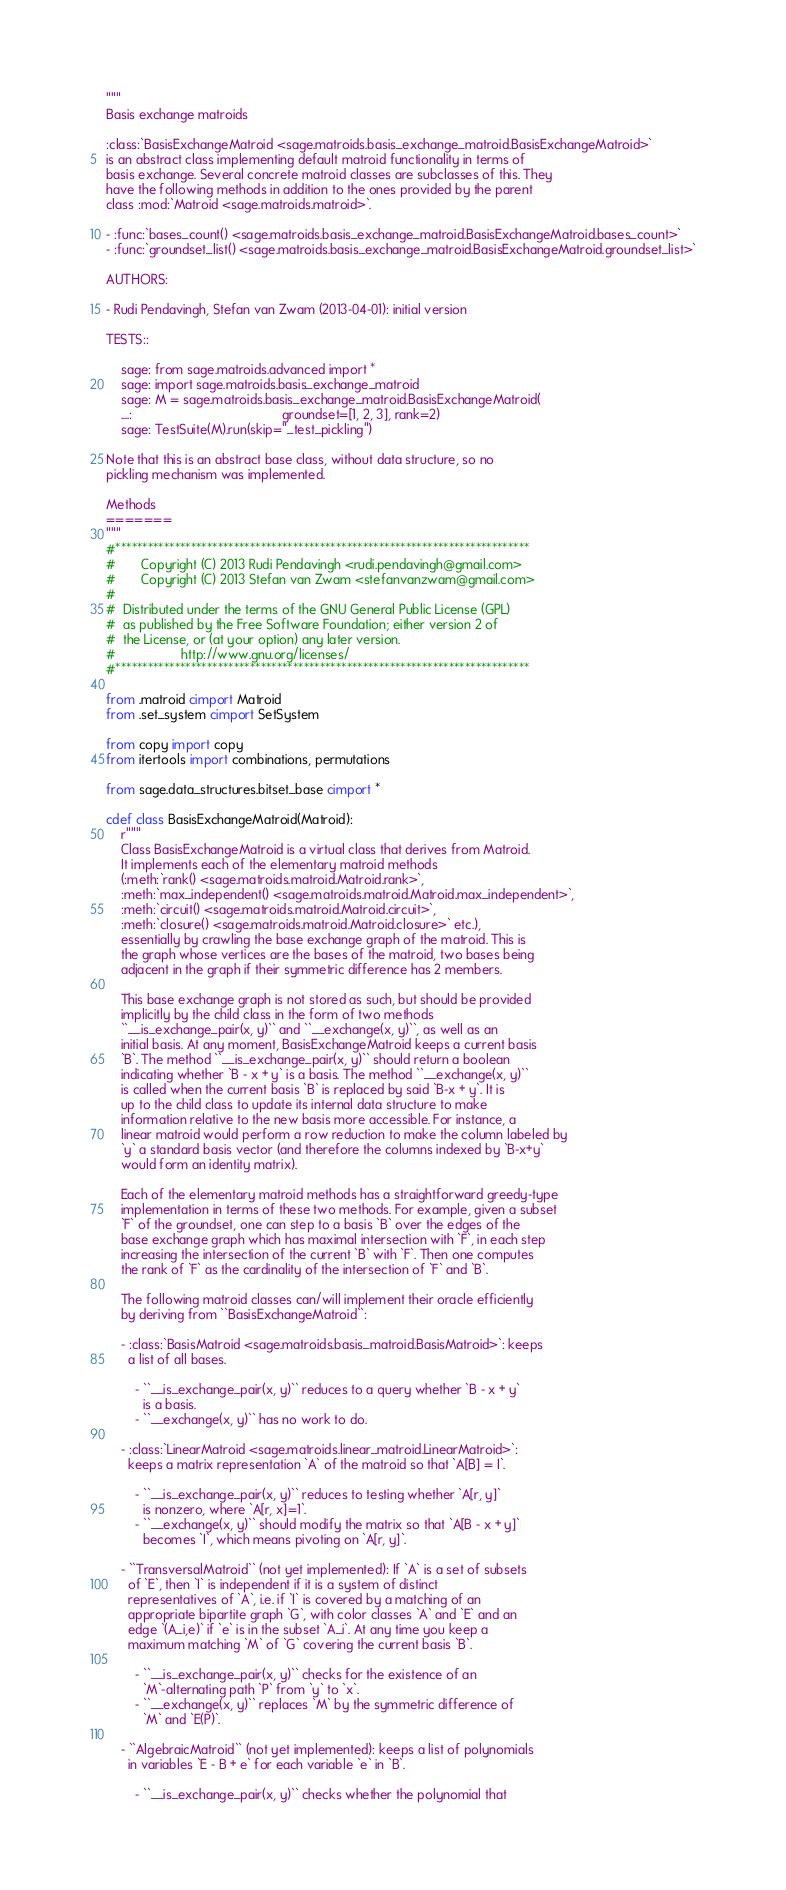<code> <loc_0><loc_0><loc_500><loc_500><_Cython_>"""
Basis exchange matroids

:class:`BasisExchangeMatroid <sage.matroids.basis_exchange_matroid.BasisExchangeMatroid>`
is an abstract class implementing default matroid functionality in terms of
basis exchange. Several concrete matroid classes are subclasses of this. They
have the following methods in addition to the ones provided by the parent
class :mod:`Matroid <sage.matroids.matroid>`.

- :func:`bases_count() <sage.matroids.basis_exchange_matroid.BasisExchangeMatroid.bases_count>`
- :func:`groundset_list() <sage.matroids.basis_exchange_matroid.BasisExchangeMatroid.groundset_list>`

AUTHORS:

- Rudi Pendavingh, Stefan van Zwam (2013-04-01): initial version

TESTS::

    sage: from sage.matroids.advanced import *
    sage: import sage.matroids.basis_exchange_matroid
    sage: M = sage.matroids.basis_exchange_matroid.BasisExchangeMatroid(
    ....:                                         groundset=[1, 2, 3], rank=2)
    sage: TestSuite(M).run(skip="_test_pickling")

Note that this is an abstract base class, without data structure, so no
pickling mechanism was implemented.

Methods
=======
"""
#*****************************************************************************
#       Copyright (C) 2013 Rudi Pendavingh <rudi.pendavingh@gmail.com>
#       Copyright (C) 2013 Stefan van Zwam <stefanvanzwam@gmail.com>
#
#  Distributed under the terms of the GNU General Public License (GPL)
#  as published by the Free Software Foundation; either version 2 of
#  the License, or (at your option) any later version.
#                  http://www.gnu.org/licenses/
#*****************************************************************************

from .matroid cimport Matroid
from .set_system cimport SetSystem

from copy import copy
from itertools import combinations, permutations

from sage.data_structures.bitset_base cimport *

cdef class BasisExchangeMatroid(Matroid):
    r"""
    Class BasisExchangeMatroid is a virtual class that derives from Matroid.
    It implements each of the elementary matroid methods
    (:meth:`rank() <sage.matroids.matroid.Matroid.rank>`,
    :meth:`max_independent() <sage.matroids.matroid.Matroid.max_independent>`,
    :meth:`circuit() <sage.matroids.matroid.Matroid.circuit>`,
    :meth:`closure() <sage.matroids.matroid.Matroid.closure>` etc.),
    essentially by crawling the base exchange graph of the matroid. This is
    the graph whose vertices are the bases of the matroid, two bases being
    adjacent in the graph if their symmetric difference has 2 members.

    This base exchange graph is not stored as such, but should be provided
    implicitly by the child class in the form of two methods
    ``__is_exchange_pair(x, y)`` and ``__exchange(x, y)``, as well as an
    initial basis. At any moment, BasisExchangeMatroid keeps a current basis
    `B`. The method ``__is_exchange_pair(x, y)`` should return a boolean
    indicating whether `B - x + y` is a basis. The method ``__exchange(x, y)``
    is called when the current basis `B` is replaced by said `B-x + y`. It is
    up to the child class to update its internal data structure to make
    information relative to the new basis more accessible. For instance, a
    linear matroid would perform a row reduction to make the column labeled by
    `y` a standard basis vector (and therefore the columns indexed by `B-x+y`
    would form an identity matrix).

    Each of the elementary matroid methods has a straightforward greedy-type
    implementation in terms of these two methods. For example, given a subset
    `F` of the groundset, one can step to a basis `B` over the edges of the
    base exchange graph which has maximal intersection with `F`, in each step
    increasing the intersection of the current `B` with `F`. Then one computes
    the rank of `F` as the cardinality of the intersection of `F` and `B`.

    The following matroid classes can/will implement their oracle efficiently
    by deriving from ``BasisExchangeMatroid``:

    - :class:`BasisMatroid <sage.matroids.basis_matroid.BasisMatroid>`: keeps
      a list of all bases.

        - ``__is_exchange_pair(x, y)`` reduces to a query whether `B - x + y`
          is a basis.
        - ``__exchange(x, y)`` has no work to do.

    - :class:`LinearMatroid <sage.matroids.linear_matroid.LinearMatroid>`:
      keeps a matrix representation `A` of the matroid so that `A[B] = I`.

        - ``__is_exchange_pair(x, y)`` reduces to testing whether `A[r, y]`
          is nonzero, where `A[r, x]=1`.
        - ``__exchange(x, y)`` should modify the matrix so that `A[B - x + y]`
          becomes `I`, which means pivoting on `A[r, y]`.

    - ``TransversalMatroid`` (not yet implemented): If `A` is a set of subsets
      of `E`, then `I` is independent if it is a system of distinct
      representatives of `A`, i.e. if `I` is covered by a matching of an
      appropriate bipartite graph `G`, with color classes `A` and `E` and an
      edge `(A_i,e)` if `e` is in the subset `A_i`. At any time you keep a
      maximum matching `M` of `G` covering the current basis `B`.

        - ``__is_exchange_pair(x, y)`` checks for the existence of an
          `M`-alternating path `P` from `y` to `x`.
        - ``__exchange(x, y)`` replaces `M` by the symmetric difference of
          `M` and `E(P)`.

    - ``AlgebraicMatroid`` (not yet implemented): keeps a list of polynomials
      in variables `E - B + e` for each variable `e` in `B`.

        - ``__is_exchange_pair(x, y)`` checks whether the polynomial that</code> 